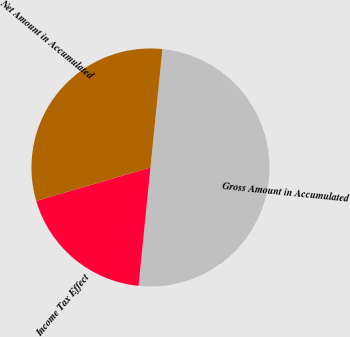Convert chart to OTSL. <chart><loc_0><loc_0><loc_500><loc_500><pie_chart><fcel>Gross Amount in Accumulated<fcel>Income Tax Effect<fcel>Net Amount in Accumulated<nl><fcel>50.0%<fcel>18.87%<fcel>31.13%<nl></chart> 